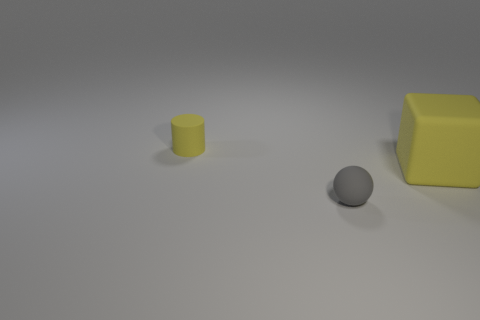Add 3 blocks. How many objects exist? 6 Subtract 1 spheres. How many spheres are left? 0 Subtract all blocks. How many objects are left? 2 Add 3 big yellow matte blocks. How many big yellow matte blocks are left? 4 Add 3 tiny gray matte spheres. How many tiny gray matte spheres exist? 4 Subtract 1 gray spheres. How many objects are left? 2 Subtract all gray cubes. Subtract all gray balls. How many cubes are left? 1 Subtract all small cylinders. Subtract all yellow objects. How many objects are left? 0 